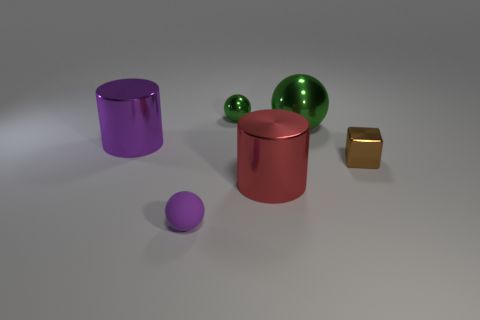Add 1 purple metal objects. How many objects exist? 7 Subtract all cylinders. How many objects are left? 4 Subtract all small metallic cylinders. Subtract all large purple cylinders. How many objects are left? 5 Add 4 green metal spheres. How many green metal spheres are left? 6 Add 3 large purple metal things. How many large purple metal things exist? 4 Subtract 0 cyan blocks. How many objects are left? 6 